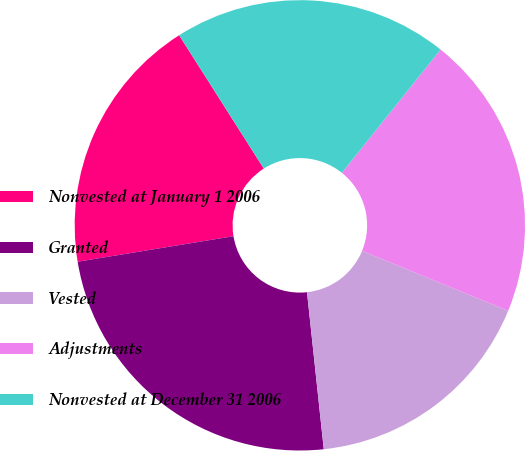Convert chart to OTSL. <chart><loc_0><loc_0><loc_500><loc_500><pie_chart><fcel>Nonvested at January 1 2006<fcel>Granted<fcel>Vested<fcel>Adjustments<fcel>Nonvested at December 31 2006<nl><fcel>18.58%<fcel>24.11%<fcel>17.11%<fcel>20.45%<fcel>19.75%<nl></chart> 